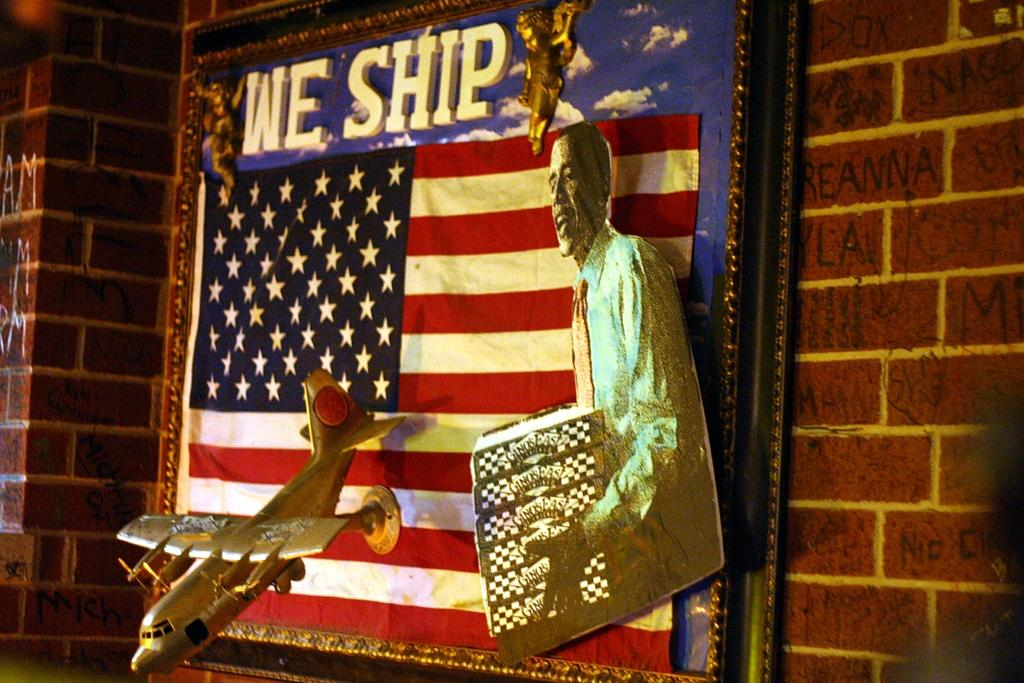What is the main subject in the center of the image? There is a wall with a photo frame in the center of the image. What is depicted within the photo frame? The photo frame contains a depiction of a person and an aeroplane. Can you describe any other elements in the image? There is a flag in the image. Where are the books located in the image? There are no books present in the image. Is there a farm visible in the image? There is no farm visible in the image. 